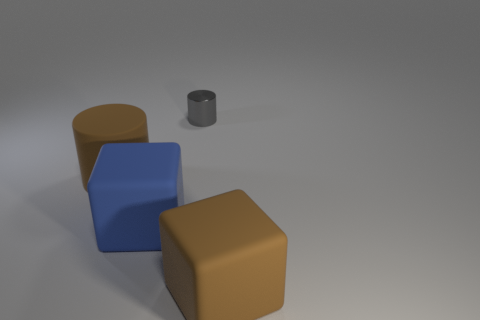What is the material of the block that is right of the tiny gray metal cylinder?
Give a very brief answer. Rubber. Are there the same number of big blue things that are to the left of the big brown cylinder and brown rubber cylinders that are in front of the brown matte block?
Provide a succinct answer. Yes. Is the size of the brown object that is in front of the brown matte cylinder the same as the shiny thing that is behind the large blue cube?
Offer a very short reply. No. What number of tiny metallic things have the same color as the big cylinder?
Offer a terse response. 0. There is a large object that is the same color as the big matte cylinder; what material is it?
Offer a terse response. Rubber. Are there more large brown cubes in front of the gray thing than large gray matte spheres?
Provide a short and direct response. Yes. Does the small shiny thing have the same shape as the big blue matte thing?
Your answer should be compact. No. What number of yellow objects are the same material as the large blue thing?
Provide a succinct answer. 0. Is the brown rubber cylinder the same size as the brown rubber cube?
Give a very brief answer. Yes. The brown object on the right side of the brown matte thing that is on the left side of the rubber thing that is to the right of the blue cube is what shape?
Make the answer very short. Cube. 